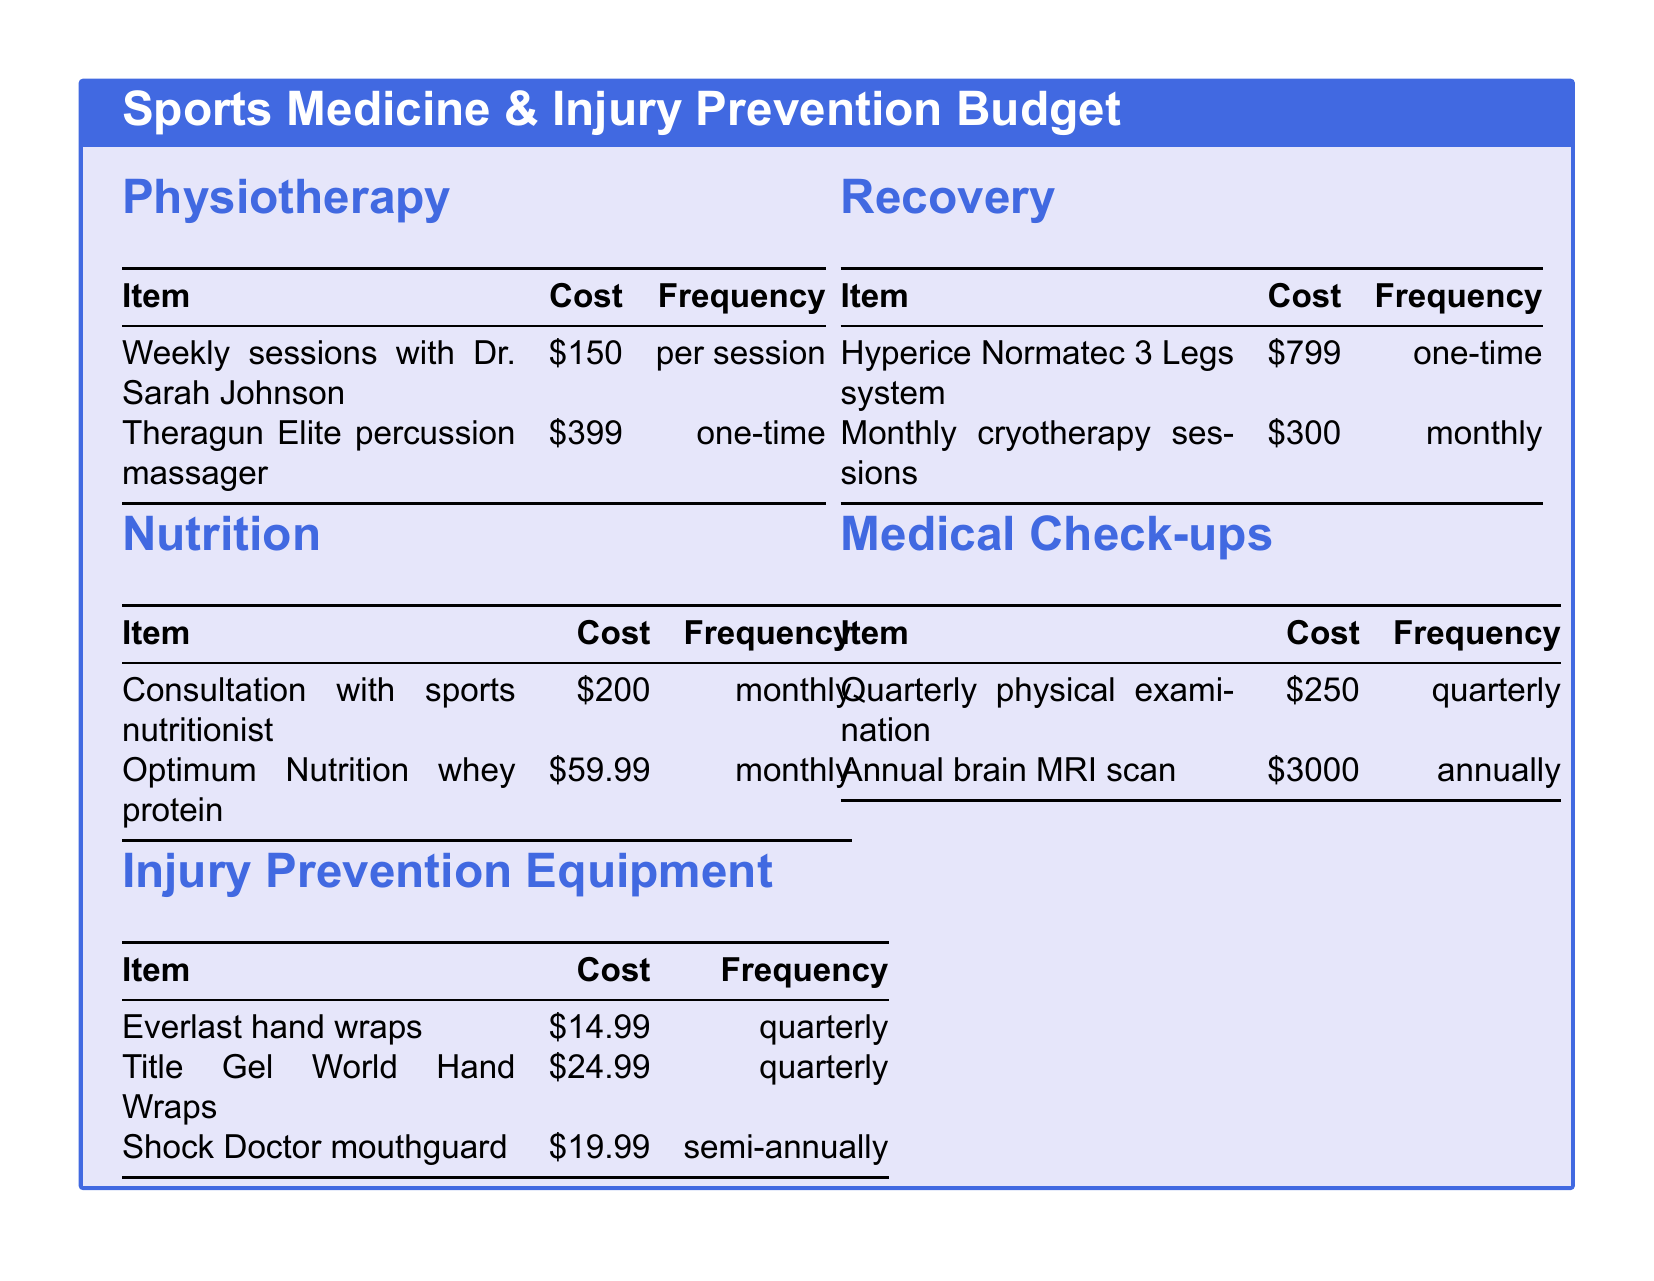What is the cost of weekly physiotherapy sessions? The cost for weekly sessions with Dr. Sarah Johnson is provided in the physiotherapy section of the budget.
Answer: 150 How frequently are consultations with the sports nutritionist needed? The frequency for consultation with the sports nutritionist is stated in the nutrition section of the budget.
Answer: monthly What is the one-time cost of the Hyperice Normatec 3 Legs system? The document lists the cost of the Hyperice Normatec 3 Legs system in the recovery section.
Answer: 799 How often do you need to replace the Everlast hand wraps? The document specifies the frequency for purchasing Everlast hand wraps in the injury prevention equipment section.
Answer: quarterly What is the total annual cost for the quarterly physical examinations? The total annual cost can be calculated from the cost per examination and the frequency stated in the medical check-ups section.
Answer: 1000 What is the monthly cost for cryotherapy sessions? The document indicates the monthly cost for cryotherapy sessions in the recovery section.
Answer: 300 What is the total frequency for the injury prevention equipment purchases? The total frequency can be determined by adding the frequencies of all items listed under injury prevention equipment.
Answer: 4 times a year How much does the annual brain MRI scan cost? The annual brain MRI scan cost is listed in the medical check-ups section of the budget.
Answer: 3000 What type of item is the Theragun Elite? The Theragun Elite is categorized under physiotherapy in the budget document.
Answer: percussion massager 